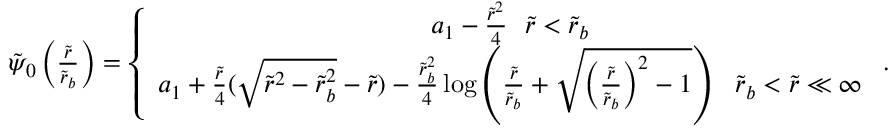<formula> <loc_0><loc_0><loc_500><loc_500>\begin{array} { r } { \tilde { \psi } _ { 0 } \left ( \frac { \tilde { r } } { \tilde { r } _ { b } } \right ) = \left \{ \begin{array} { c } { a _ { 1 } - \frac { \tilde { r } ^ { 2 } } { 4 } \tilde { r } < \tilde { r } _ { b } } \\ { a _ { 1 } + \frac { \tilde { r } } { 4 } ( \sqrt { \tilde { r } ^ { 2 } - \tilde { r } _ { b } ^ { 2 } } - \tilde { r } ) - \frac { \tilde { r } _ { b } ^ { 2 } } { 4 } \log \left ( \frac { \tilde { r } } { \tilde { r } _ { b } } + \sqrt { \left ( \frac { \tilde { r } } { \tilde { r } _ { b } } \right ) ^ { 2 } - 1 } \right ) \tilde { r } _ { b } < \tilde { r } \ll \infty } \end{array} . } \end{array}</formula> 